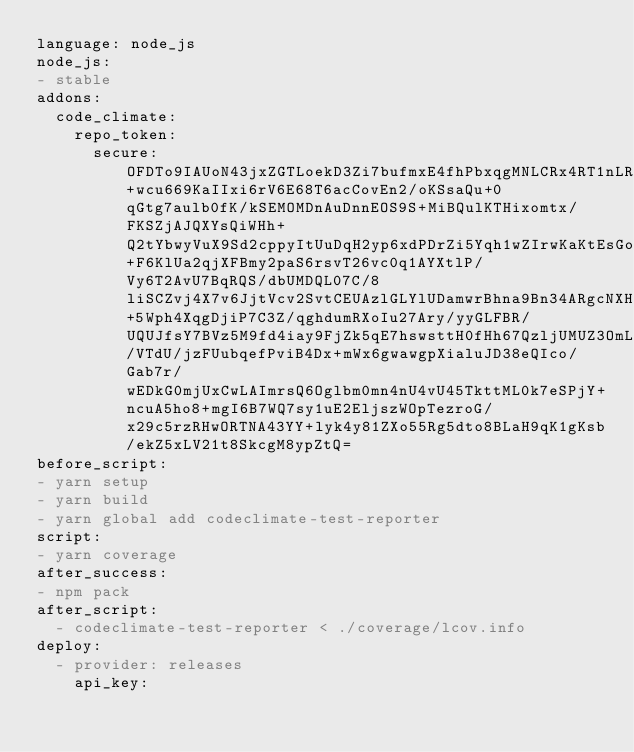Convert code to text. <code><loc_0><loc_0><loc_500><loc_500><_YAML_>language: node_js
node_js:
- stable
addons:
  code_climate:
    repo_token:
      secure: OFDTo9IAUoN43jxZGTLoekD3Zi7bufmxE4fhPbxqgMNLCRx4RT1nLRrGOZH+wcu669KaIIxi6rV6E68T6acCovEn2/oKSsaQu+0qGtg7aulb0fK/kSEMOMDnAuDnnEOS9S+MiBQulKTHixomtx/FKSZjAJQXYsQiWHh+Q2tYbwyVuX9Sd2cppyItUuDqH2yp6xdPDrZi5Yqh1wZIrwKaKtEsGomOgp4n1LR8vVzS3dhzBVK2c+F6KlUa2qjXFBmy2paS6rsvT26vc0q1AYXtlP/Vy6T2AvU7BqRQS/dbUMDQL07C/8liSCZvj4X7v6JjtVcv2SvtCEUAzlGLYlUDamwrBhna9Bn34ARgcNXH+5Wph4XqgDjiP7C3Z/qghdumRXoIu27Ary/yyGLFBR/UQUJfsY7BVz5M9fd4iay9FjZk5qE7hswsttH0fHh67QzljUMUZ3OmLeFnHKm6h/VTdU/jzFUubqefPviB4Dx+mWx6gwawgpXialuJD38eQIco/Gab7r/wEDkG0mjUxCwLAImrsQ6Oglbm0mn4nU4vU45TkttML0k7eSPjY+ncuA5ho8+mgI6B7WQ7sy1uE2EljszWOpTezroG/x29c5rzRHwORTNA43YY+lyk4y81ZXo55Rg5dto8BLaH9qK1gKsb/ekZ5xLV21t8SkcgM8ypZtQ=
before_script:
- yarn setup
- yarn build
- yarn global add codeclimate-test-reporter
script:
- yarn coverage
after_success:
- npm pack
after_script:
  - codeclimate-test-reporter < ./coverage/lcov.info
deploy:
  - provider: releases
    api_key:</code> 